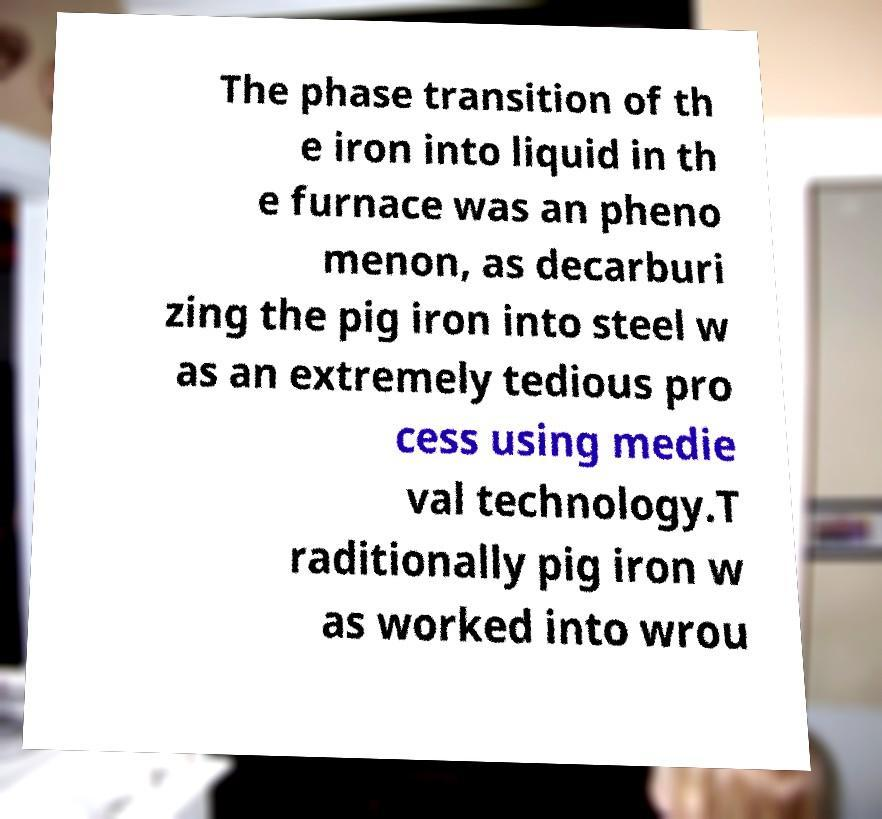Can you read and provide the text displayed in the image?This photo seems to have some interesting text. Can you extract and type it out for me? The phase transition of th e iron into liquid in th e furnace was an pheno menon, as decarburi zing the pig iron into steel w as an extremely tedious pro cess using medie val technology.T raditionally pig iron w as worked into wrou 